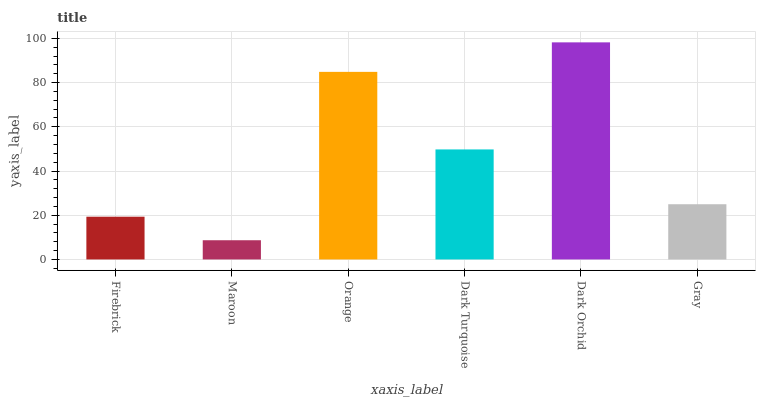Is Maroon the minimum?
Answer yes or no. Yes. Is Dark Orchid the maximum?
Answer yes or no. Yes. Is Orange the minimum?
Answer yes or no. No. Is Orange the maximum?
Answer yes or no. No. Is Orange greater than Maroon?
Answer yes or no. Yes. Is Maroon less than Orange?
Answer yes or no. Yes. Is Maroon greater than Orange?
Answer yes or no. No. Is Orange less than Maroon?
Answer yes or no. No. Is Dark Turquoise the high median?
Answer yes or no. Yes. Is Gray the low median?
Answer yes or no. Yes. Is Dark Orchid the high median?
Answer yes or no. No. Is Orange the low median?
Answer yes or no. No. 